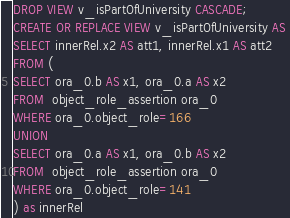<code> <loc_0><loc_0><loc_500><loc_500><_SQL_>DROP VIEW v_isPartOfUniversity CASCADE;
CREATE OR REPLACE VIEW v_isPartOfUniversity AS 
SELECT innerRel.x2 AS att1, innerRel.x1 AS att2
FROM (
SELECT ora_0.b AS x1, ora_0.a AS x2
FROM  object_role_assertion ora_0
WHERE ora_0.object_role=166
UNION 
SELECT ora_0.a AS x1, ora_0.b AS x2
FROM  object_role_assertion ora_0
WHERE ora_0.object_role=141
) as innerRel
</code> 